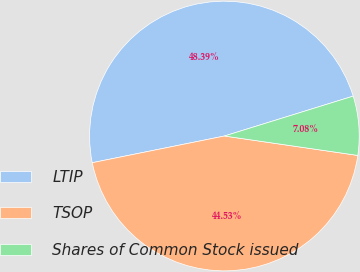Convert chart. <chart><loc_0><loc_0><loc_500><loc_500><pie_chart><fcel>LTIP<fcel>TSOP<fcel>Shares of Common Stock issued<nl><fcel>48.39%<fcel>44.53%<fcel>7.08%<nl></chart> 